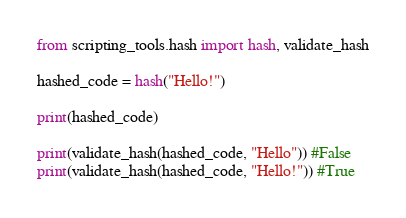Convert code to text. <code><loc_0><loc_0><loc_500><loc_500><_Python_>from scripting_tools.hash import hash, validate_hash

hashed_code = hash("Hello!")

print(hashed_code)

print(validate_hash(hashed_code, "Hello")) #False
print(validate_hash(hashed_code, "Hello!")) #True</code> 